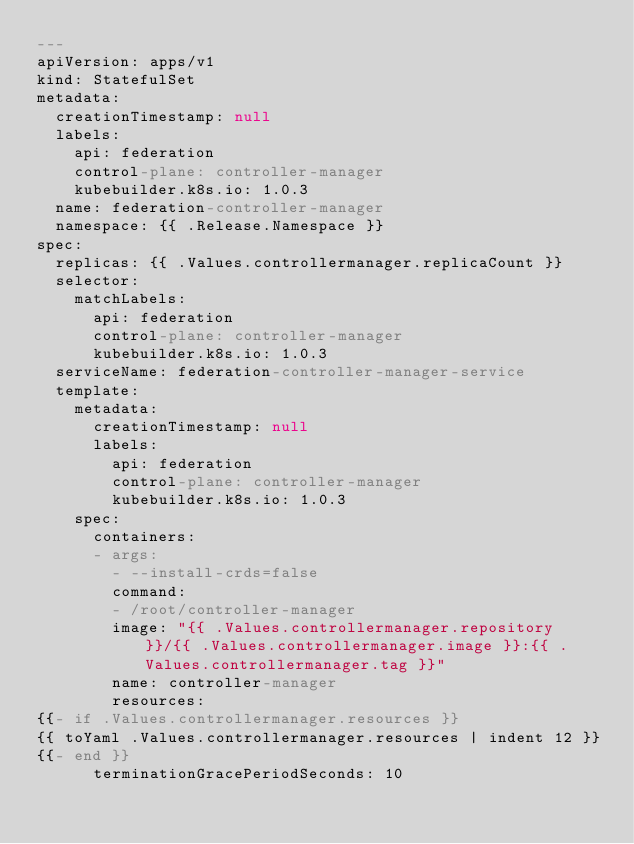Convert code to text. <code><loc_0><loc_0><loc_500><loc_500><_YAML_>---
apiVersion: apps/v1
kind: StatefulSet
metadata:
  creationTimestamp: null
  labels:
    api: federation
    control-plane: controller-manager
    kubebuilder.k8s.io: 1.0.3
  name: federation-controller-manager
  namespace: {{ .Release.Namespace }}
spec:
  replicas: {{ .Values.controllermanager.replicaCount }}
  selector:
    matchLabels:
      api: federation
      control-plane: controller-manager
      kubebuilder.k8s.io: 1.0.3
  serviceName: federation-controller-manager-service
  template:
    metadata:
      creationTimestamp: null
      labels:
        api: federation
        control-plane: controller-manager
        kubebuilder.k8s.io: 1.0.3
    spec:
      containers:
      - args:
        - --install-crds=false
        command:
        - /root/controller-manager
        image: "{{ .Values.controllermanager.repository }}/{{ .Values.controllermanager.image }}:{{ .Values.controllermanager.tag }}"
        name: controller-manager
        resources:
{{- if .Values.controllermanager.resources }}
{{ toYaml .Values.controllermanager.resources | indent 12 }}
{{- end }}
      terminationGracePeriodSeconds: 10
</code> 